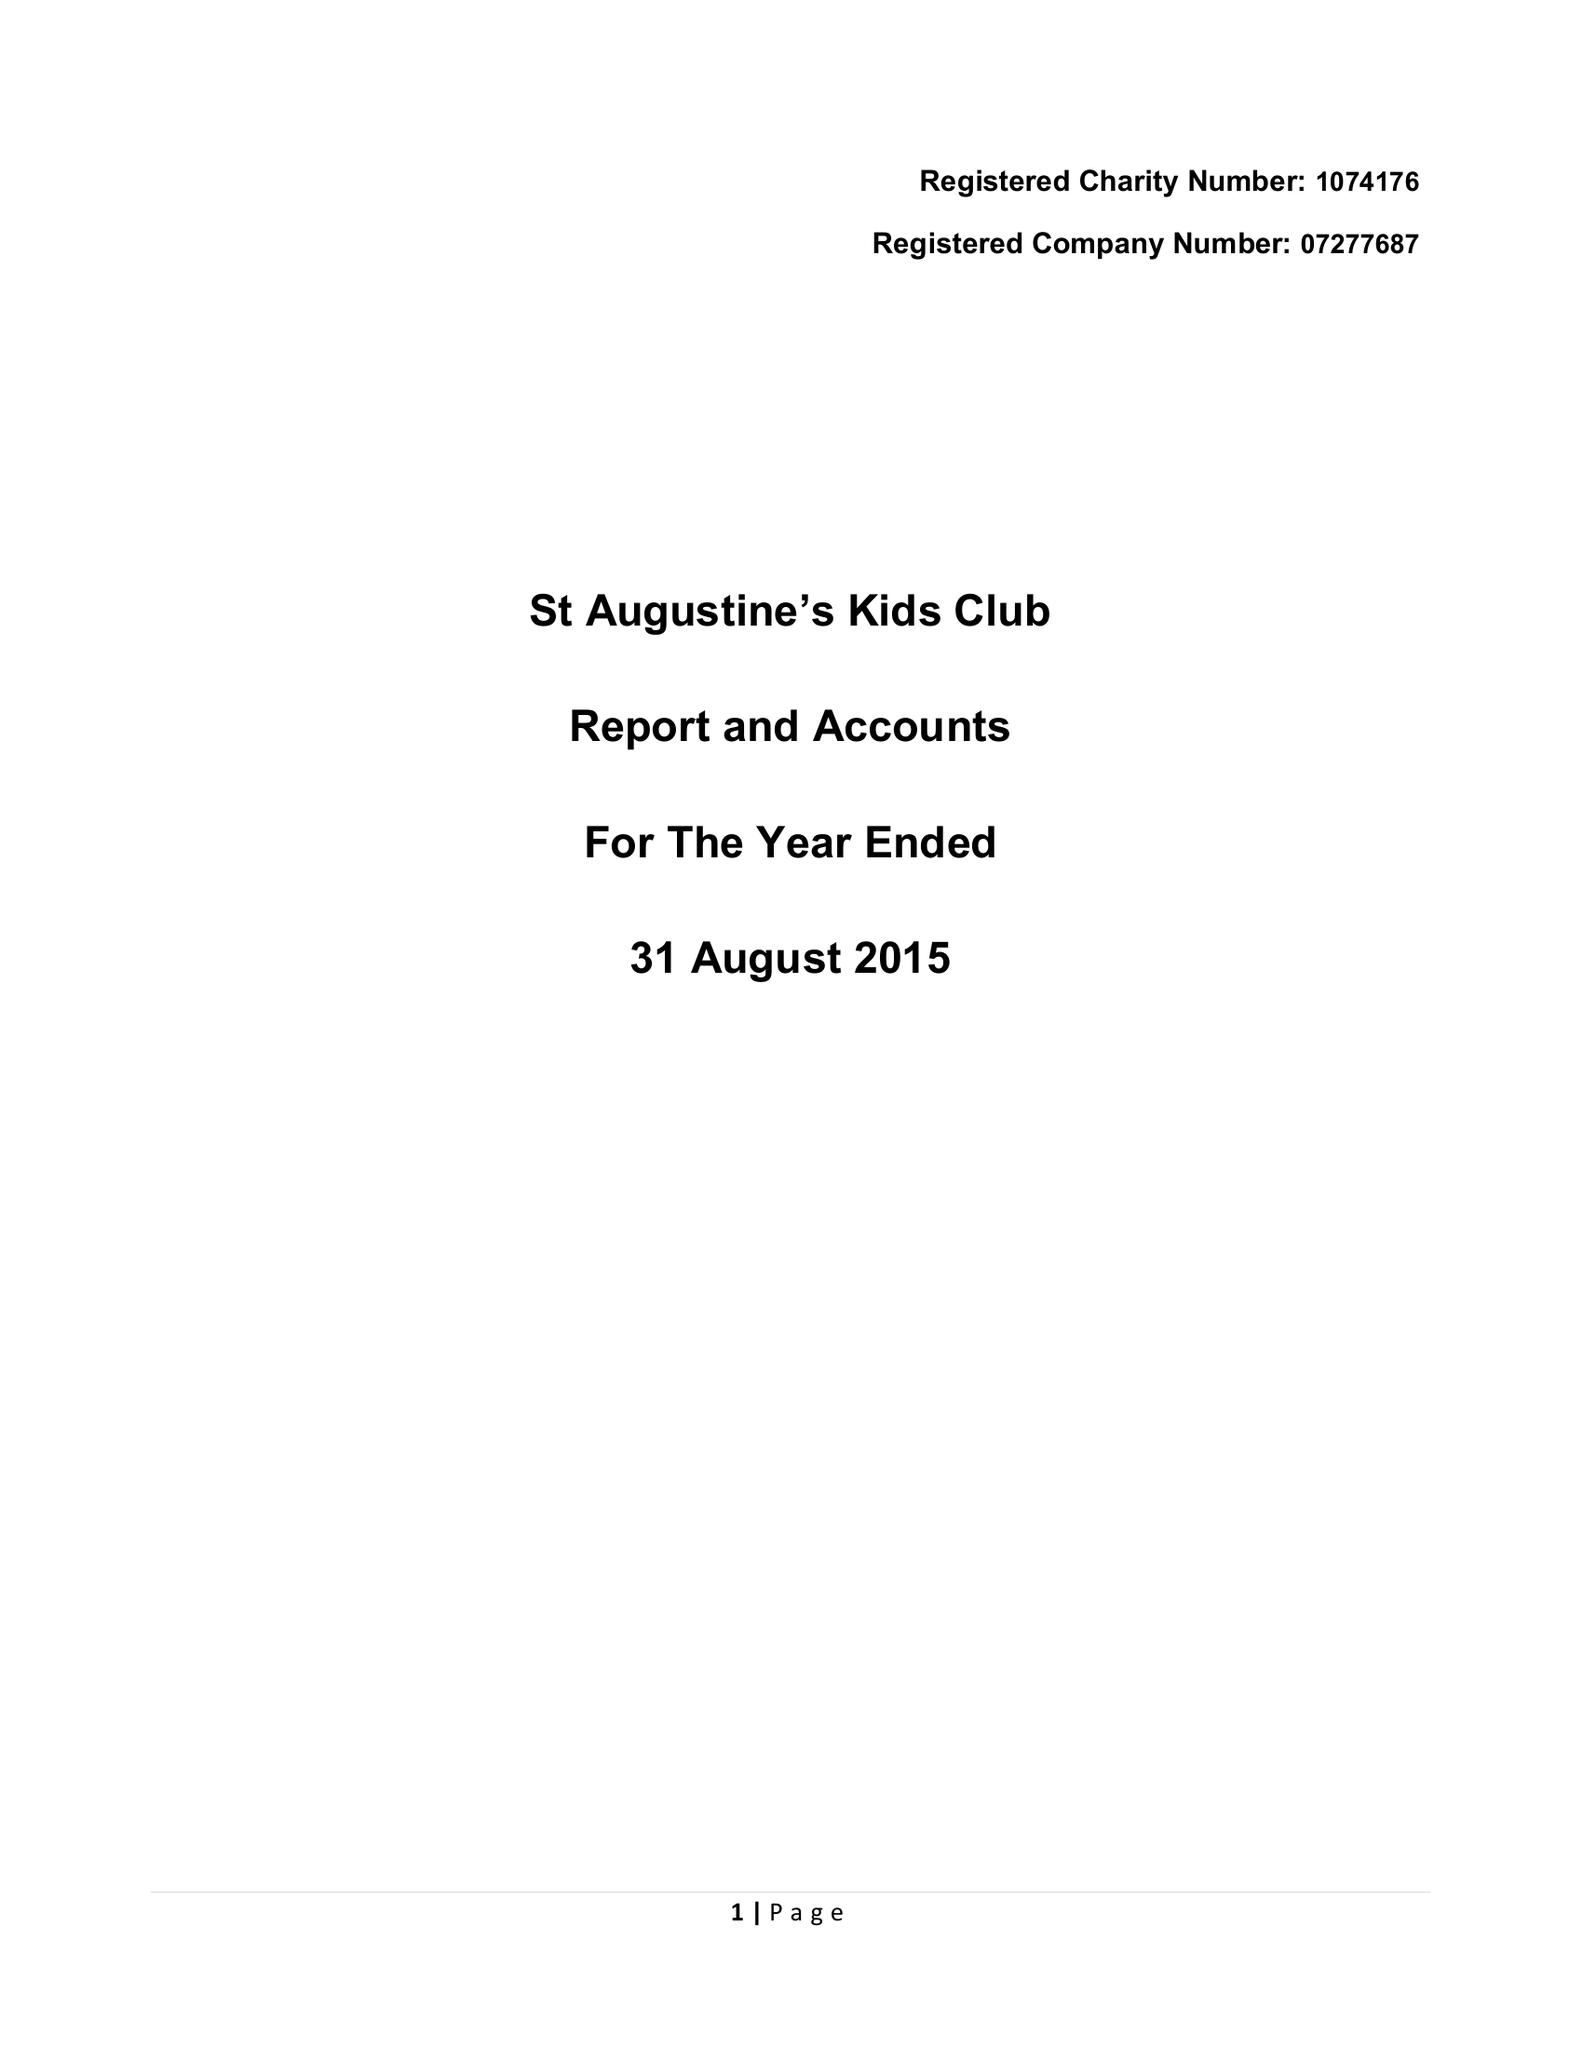What is the value for the charity_name?
Answer the question using a single word or phrase. St Augustines Kids Club 